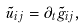Convert formula to latex. <formula><loc_0><loc_0><loc_500><loc_500>\tilde { u } _ { i j } = \partial _ { t } \tilde { g } _ { i j } ,</formula> 